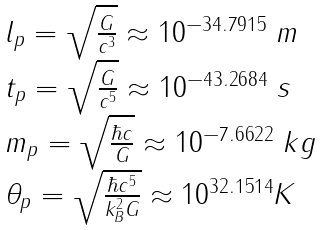<formula> <loc_0><loc_0><loc_500><loc_500>\begin{array} { l } l _ { p } = \sqrt { \frac { G } { c ^ { 3 } } } \approx 1 0 ^ { - 3 4 . 7 9 1 5 } \text { } m \\ t _ { p } = \sqrt { \frac { G } { c ^ { 5 } } } \approx 1 0 ^ { - 4 3 . 2 6 8 4 } \text { } s \quad \\ m _ { p } = \sqrt { \frac { \hbar { c } } G } \approx 1 0 ^ { - 7 . 6 6 2 2 } \text { } k g \\ \theta _ { p } = \sqrt { \frac { \hbar { c } ^ { 5 } } { k _ { B } ^ { 2 } G } } \approx 1 0 ^ { 3 2 . 1 5 1 4 } K \end{array}</formula> 